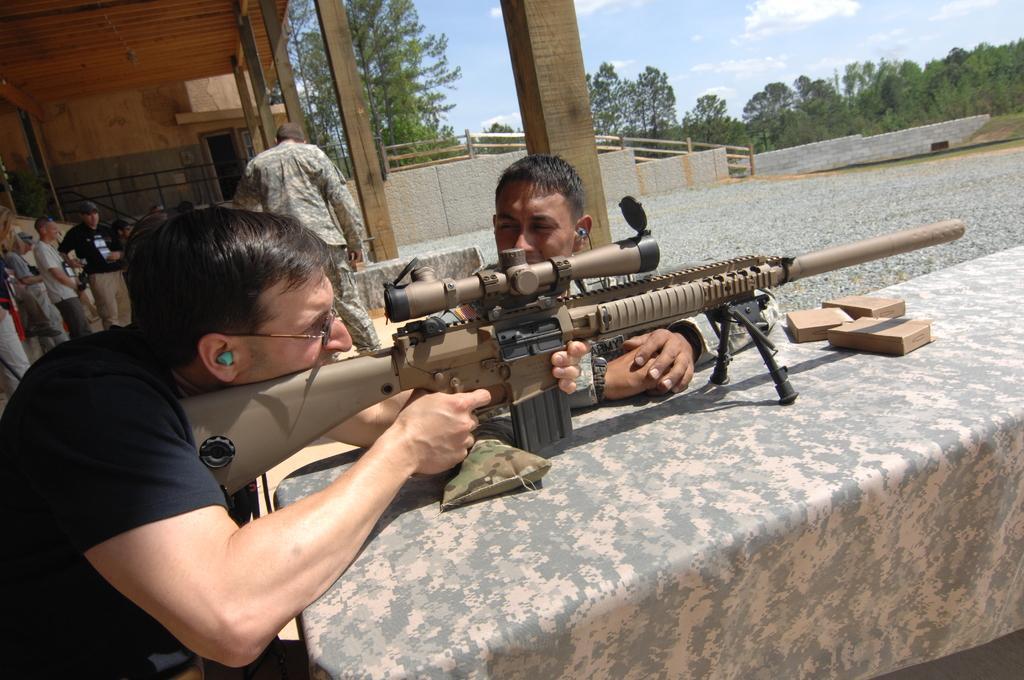Please provide a concise description of this image. In the center of the image there is a person holding gun and placed on the table. In the background we can see persons, stairs, wall, fencing, pillars, trees, sky and clouds. 